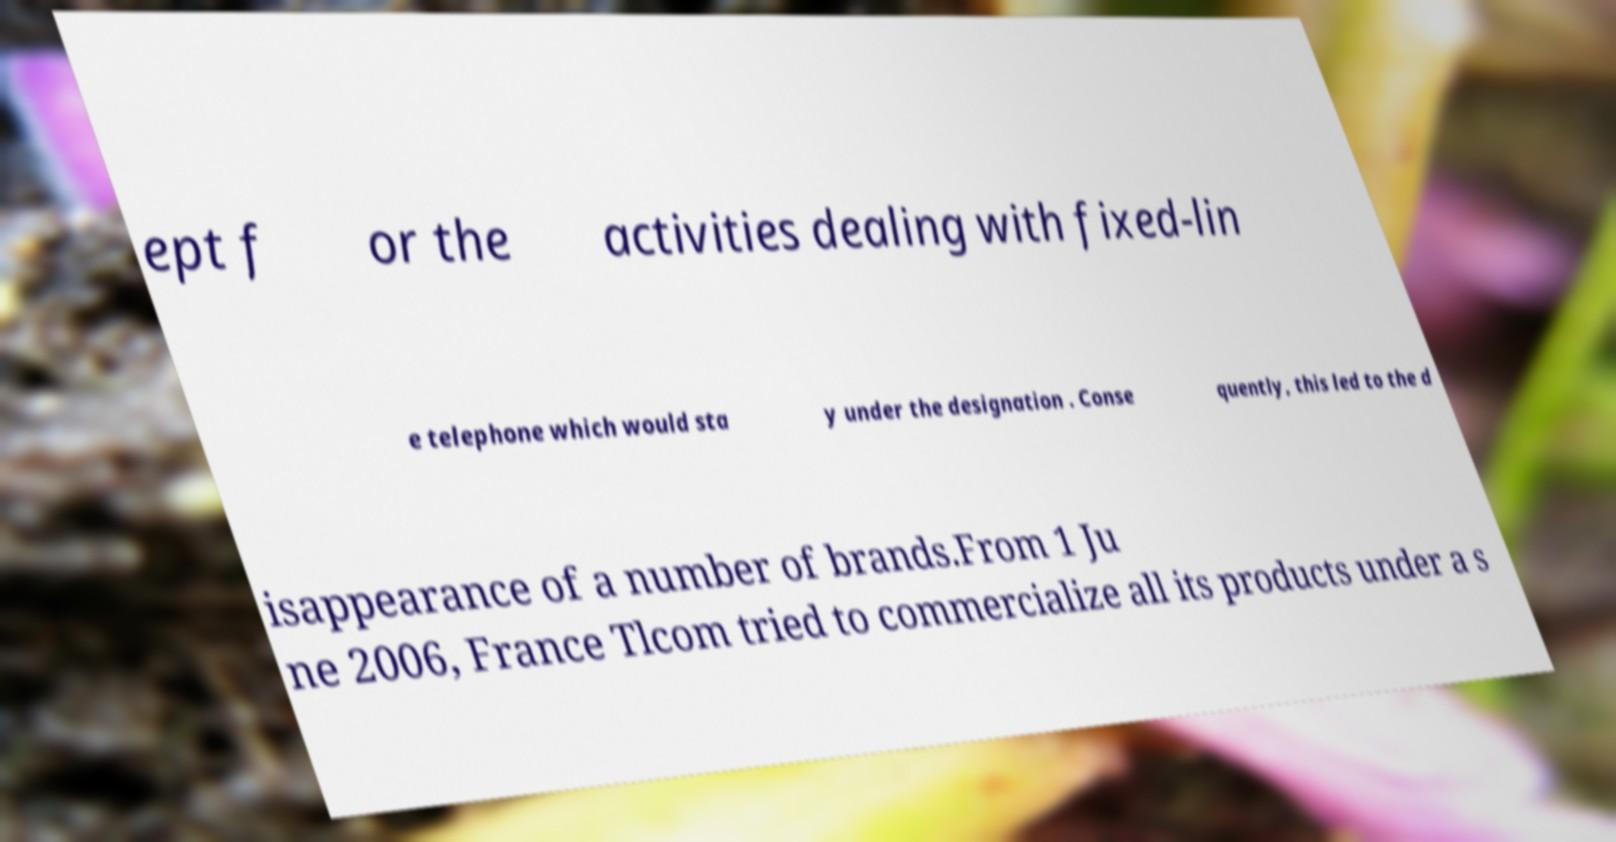Could you assist in decoding the text presented in this image and type it out clearly? ept f or the activities dealing with fixed-lin e telephone which would sta y under the designation . Conse quently, this led to the d isappearance of a number of brands.From 1 Ju ne 2006, France Tlcom tried to commercialize all its products under a s 